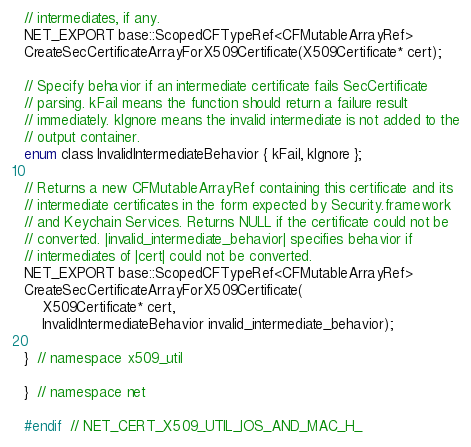<code> <loc_0><loc_0><loc_500><loc_500><_C_>// intermediates, if any.
NET_EXPORT base::ScopedCFTypeRef<CFMutableArrayRef>
CreateSecCertificateArrayForX509Certificate(X509Certificate* cert);

// Specify behavior if an intermediate certificate fails SecCertificate
// parsing. kFail means the function should return a failure result
// immediately. kIgnore means the invalid intermediate is not added to the
// output container.
enum class InvalidIntermediateBehavior { kFail, kIgnore };

// Returns a new CFMutableArrayRef containing this certificate and its
// intermediate certificates in the form expected by Security.framework
// and Keychain Services. Returns NULL if the certificate could not be
// converted. |invalid_intermediate_behavior| specifies behavior if
// intermediates of |cert| could not be converted.
NET_EXPORT base::ScopedCFTypeRef<CFMutableArrayRef>
CreateSecCertificateArrayForX509Certificate(
    X509Certificate* cert,
    InvalidIntermediateBehavior invalid_intermediate_behavior);

}  // namespace x509_util

}  // namespace net

#endif  // NET_CERT_X509_UTIL_IOS_AND_MAC_H_
</code> 